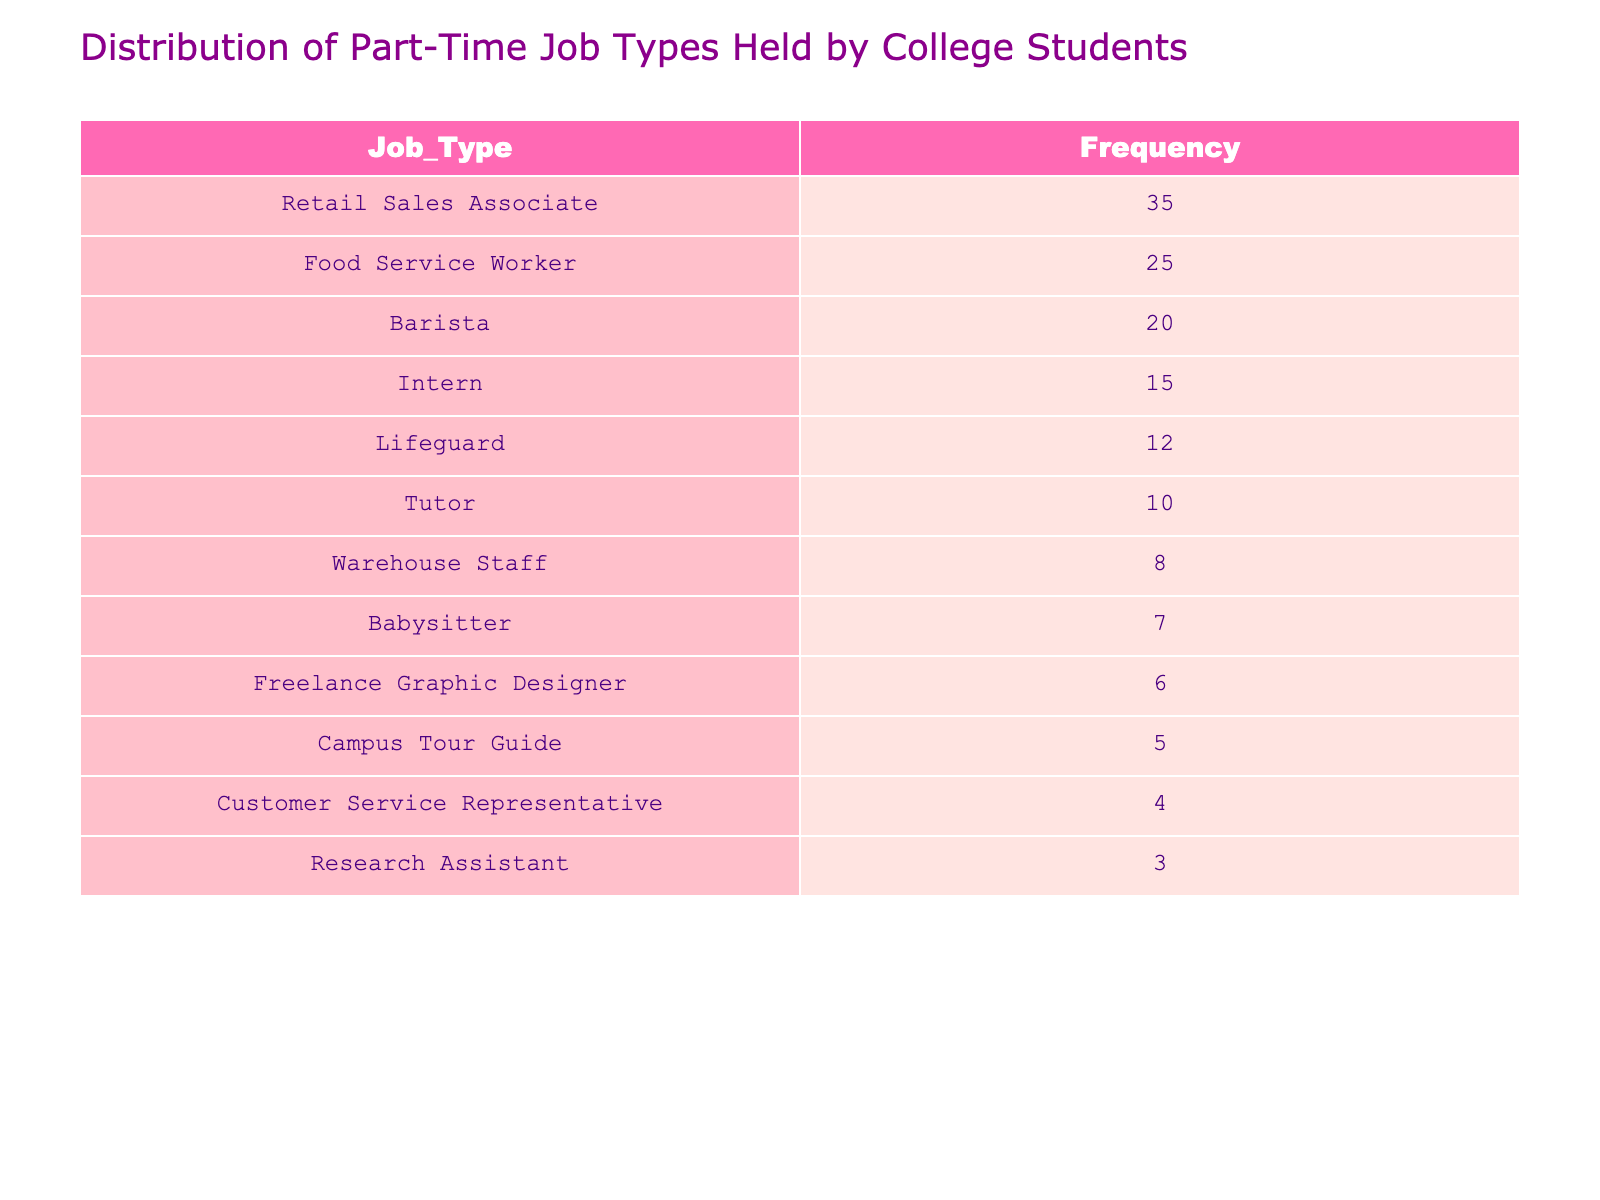What is the most common part-time job type held by college students? The table shows the frequency distribution of different job types. The job type with the highest frequency is "Retail Sales Associate" with 35 occurrences, which indicates it is the most common.
Answer: Retail Sales Associate What are the frequencies of "Food Service Worker" and "Barista"? Referring to the table, "Food Service Worker" has a frequency of 25 and "Barista" has a frequency of 20. These values can be read directly from the table.
Answer: Food Service Worker: 25, Barista: 20 Is there a part-time job type that has a frequency greater than 30? By checking the frequency values in the table, "Retail Sales Associate" is the only job type exceeding a frequency of 30, as it shows a frequency of 35. Other job types do not exceed this value.
Answer: Yes How many part-time job types have a frequency of less than 10? The table lists the job types with their frequencies, and the job types with a frequency less than 10 are "Warehouse Staff" with 8 and "Customer Service Representative" with 4, totaling 2 job types.
Answer: 2 What is the average frequency of part-time job types listed in the table? To calculate the average frequency, sum all the frequencies: 35 + 25 + 15 + 10 + 20 + 12 + 8 + 5 + 6 + 4 + 3 + 7 =  145. Then divide by the number of job types (12): 145 / 12 = approximately 12.08. Therefore, the average frequency is around 12.08.
Answer: Approximately 12.08 Which job type has a frequency closest to the median frequency among those listed? First, sort the frequencies: 3, 4, 5, 6, 7, 8, 10, 12, 15, 20, 25, 35. The median is the average of the 6th and 7th numbers in the sorted list (8 and 10), which is (8 + 10) / 2 = 9. The job type closest to the median frequency is "Babysitter" with a frequency of 7, as it is merely the closest below the median value.
Answer: Babysitter What percentage of students work in "Intern" positions compared to the total number of students in the table? The frequency for "Intern" positions is 15. First, find the total frequency: 145. Then, calculate the percentage as (15 / 145) * 100, which equals approximately 10.34%. This shows that about 10.34% of the students hold "Intern" positions.
Answer: Approximately 10.34% What is the total frequency of jobs related to customer service (Barista and Customer Service Representative)? The table lists the frequency for "Barista" as 20 and "Customer Service Representative" as 4. Adding these two gives 20 + 4 = 24, which indicates the total frequency of jobs related to customer service.
Answer: 24 